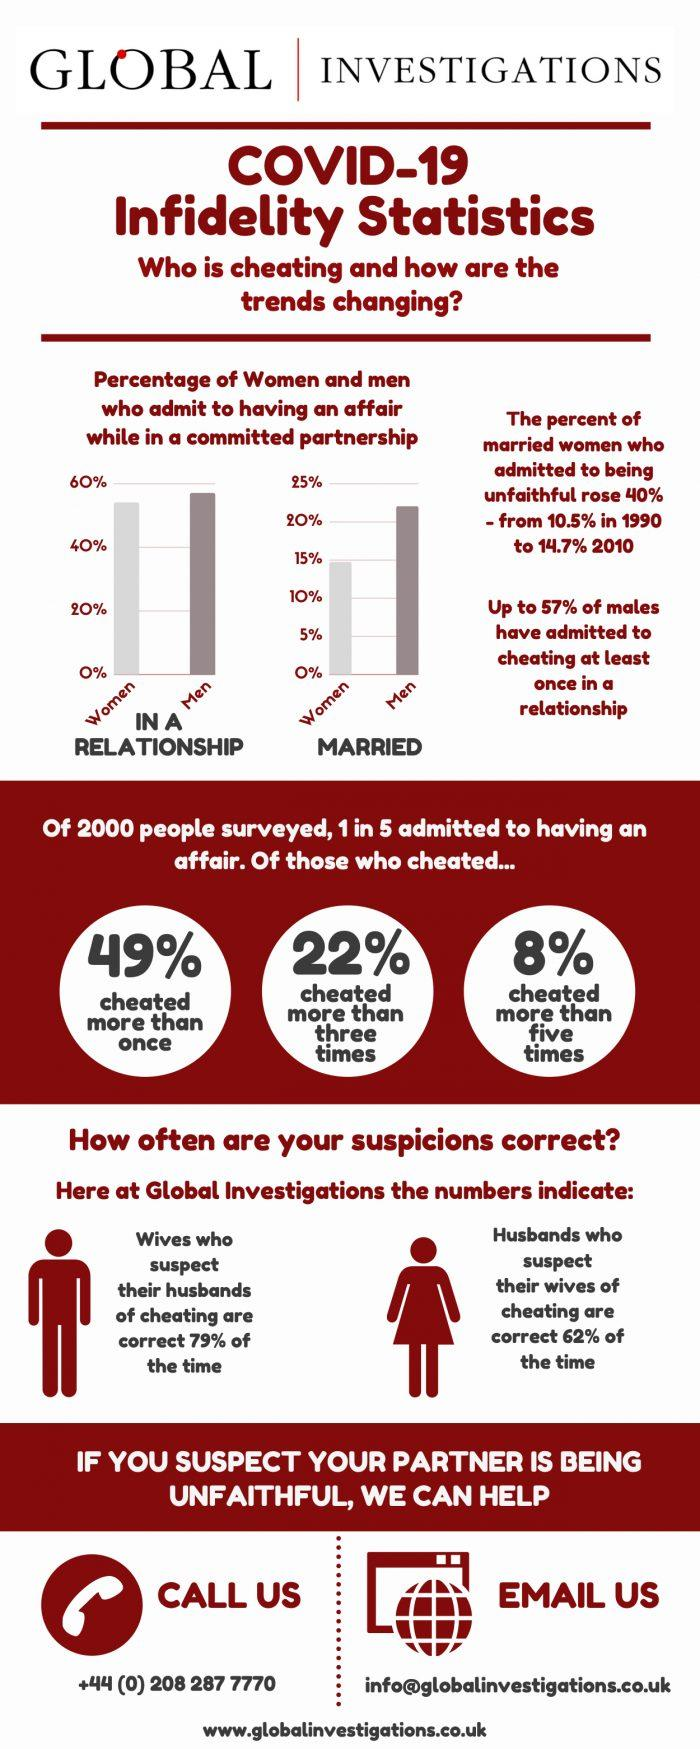Point out several critical features in this image. A study found that 62% of husbands who suspect their wives of cheating are correct. According to the survey of 2000 people, 20% of the respondents admitted to having an extramarital affair. According to a study, 79% of wives who suspect their husbands of cheating are correct in their suspicions. 